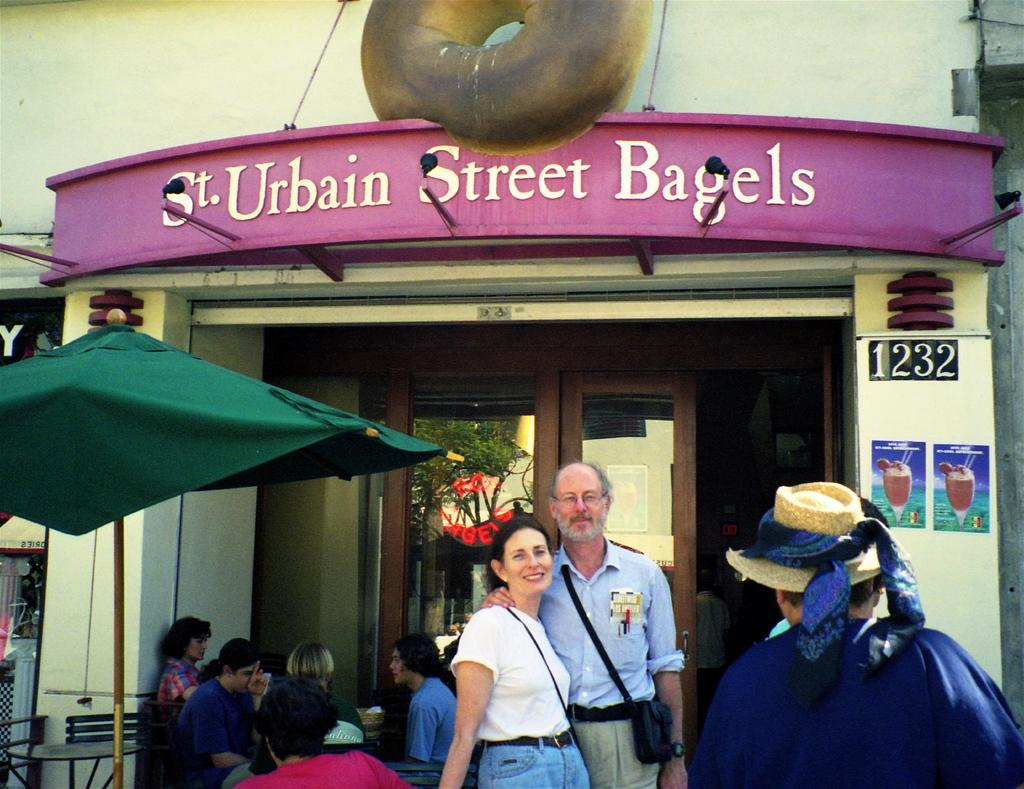Who or what can be seen in the image? There are people in the image. What type of vegetation is present in the image? There is a plant in the image. What is written or displayed on the board in the image? There is a board with text in the image. What type of furniture is in the image? There is a chair and a table in the image. What type of pocket can be seen on the plant in the image? There is no pocket present on the plant in the image, as plants do not have pockets. 